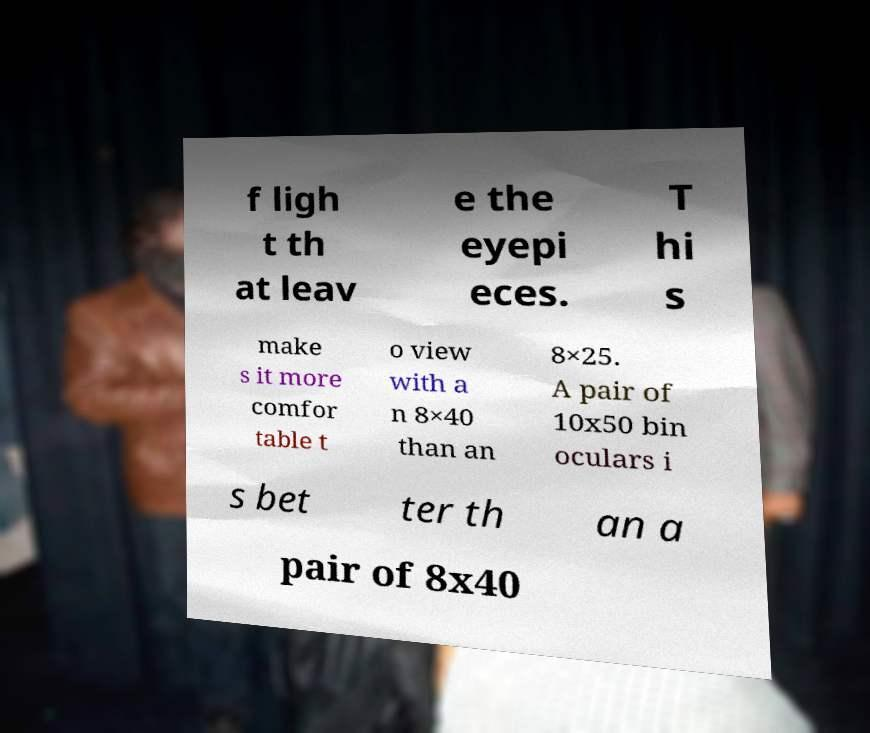Can you accurately transcribe the text from the provided image for me? f ligh t th at leav e the eyepi eces. T hi s make s it more comfor table t o view with a n 8×40 than an 8×25. A pair of 10x50 bin oculars i s bet ter th an a pair of 8x40 